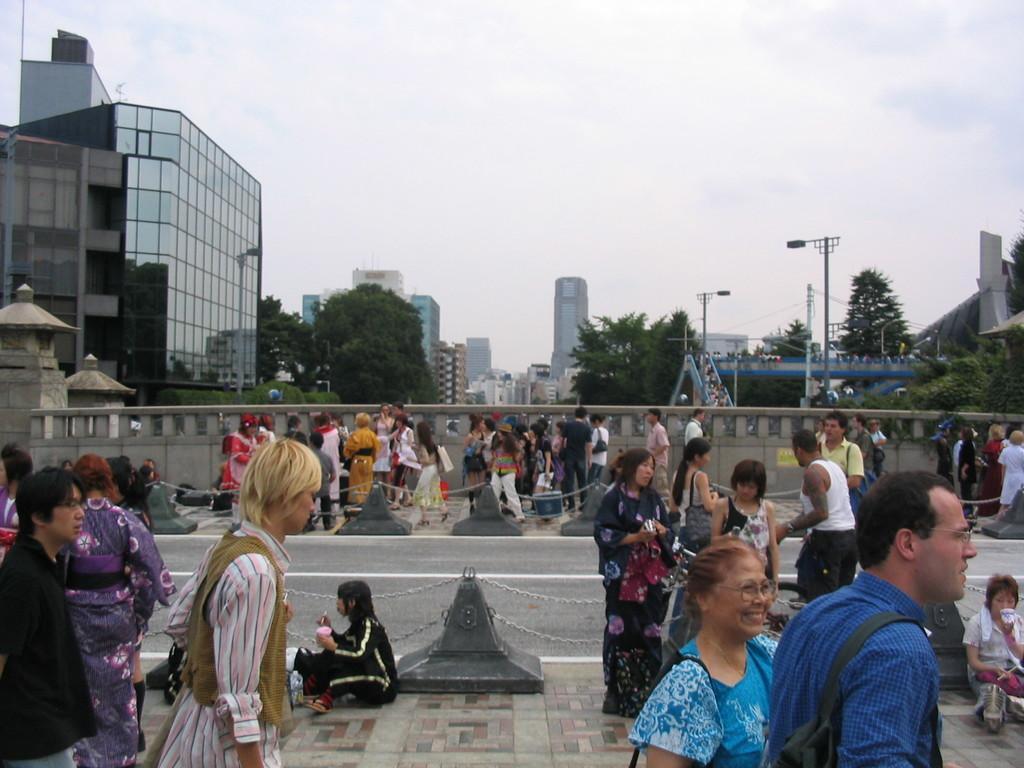In one or two sentences, can you explain what this image depicts? This is the picture of a city. In this image there are group of people walking. On the right side of the image there is a woman sitting. In the middle of the image there is a person sitting. In the middle of the image there is a road and there are railings on both sides of the road. At the back there are buildings and trees and poles. At the top there is sky and there are clouds. At the bottom there is a road. 